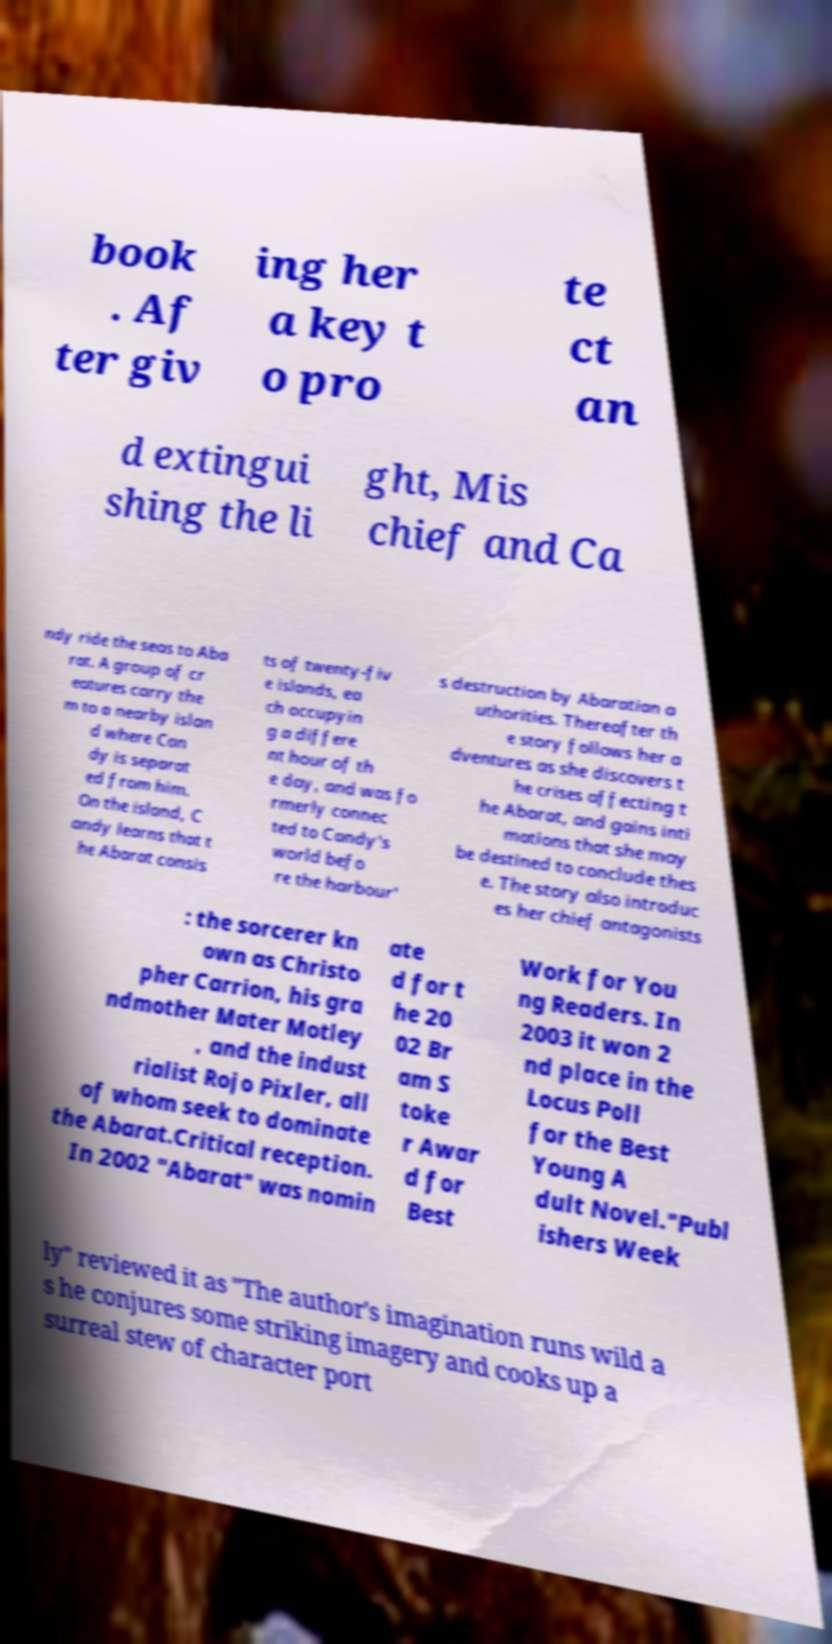Can you read and provide the text displayed in the image?This photo seems to have some interesting text. Can you extract and type it out for me? book . Af ter giv ing her a key t o pro te ct an d extingui shing the li ght, Mis chief and Ca ndy ride the seas to Aba rat. A group of cr eatures carry the m to a nearby islan d where Can dy is separat ed from him. On the island, C andy learns that t he Abarat consis ts of twenty-fiv e islands, ea ch occupyin g a differe nt hour of th e day, and was fo rmerly connec ted to Candy's world befo re the harbour' s destruction by Abaratian a uthorities. Thereafter th e story follows her a dventures as she discovers t he crises affecting t he Abarat, and gains inti mations that she may be destined to conclude thes e. The story also introduc es her chief antagonists : the sorcerer kn own as Christo pher Carrion, his gra ndmother Mater Motley , and the indust rialist Rojo Pixler, all of whom seek to dominate the Abarat.Critical reception. In 2002 "Abarat" was nomin ate d for t he 20 02 Br am S toke r Awar d for Best Work for You ng Readers. In 2003 it won 2 nd place in the Locus Poll for the Best Young A dult Novel."Publ ishers Week ly" reviewed it as "The author's imagination runs wild a s he conjures some striking imagery and cooks up a surreal stew of character port 